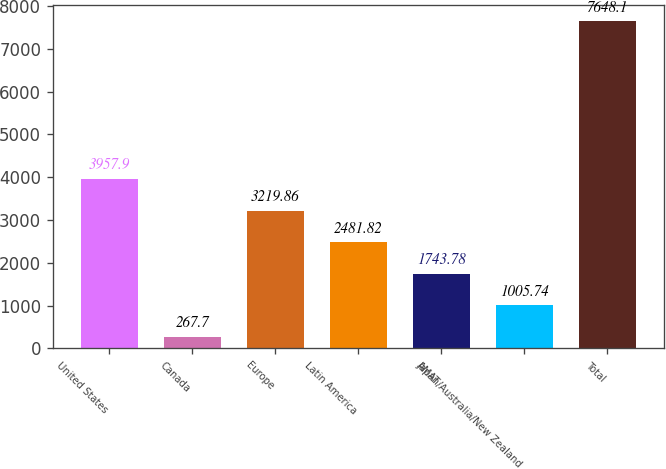Convert chart. <chart><loc_0><loc_0><loc_500><loc_500><bar_chart><fcel>United States<fcel>Canada<fcel>Europe<fcel>Latin America<fcel>AMAT<fcel>Japan/Australia/New Zealand<fcel>Total<nl><fcel>3957.9<fcel>267.7<fcel>3219.86<fcel>2481.82<fcel>1743.78<fcel>1005.74<fcel>7648.1<nl></chart> 